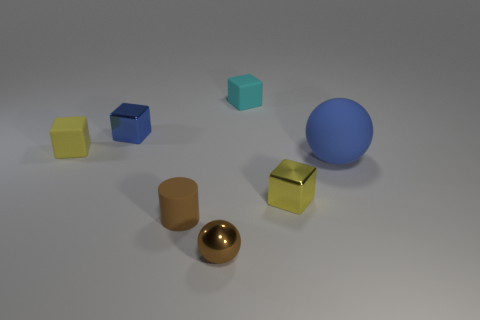Subtract all blue blocks. How many blocks are left? 3 Add 3 tiny cyan shiny blocks. How many objects exist? 10 Subtract all gray blocks. Subtract all yellow cylinders. How many blocks are left? 4 Subtract all balls. How many objects are left? 5 Add 3 blue rubber spheres. How many blue rubber spheres exist? 4 Subtract 0 purple spheres. How many objects are left? 7 Subtract all big blue cubes. Subtract all tiny brown things. How many objects are left? 5 Add 7 brown cylinders. How many brown cylinders are left? 8 